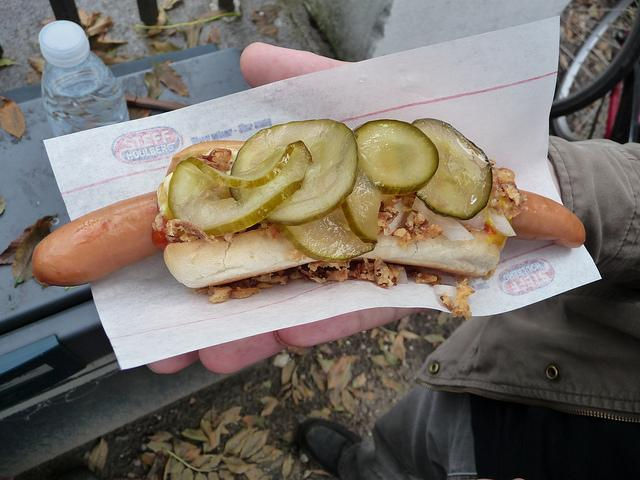What type of solution were the cucumbers soaked in? Please explain your reasoning. brine. The cucumbers are soaked in vinegar. 